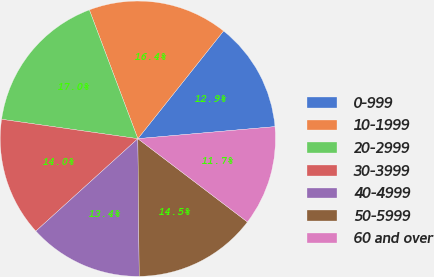<chart> <loc_0><loc_0><loc_500><loc_500><pie_chart><fcel>0-999<fcel>10-1999<fcel>20-2999<fcel>30-3999<fcel>40-4999<fcel>50-5999<fcel>60 and over<nl><fcel>12.91%<fcel>16.43%<fcel>17.02%<fcel>13.97%<fcel>13.44%<fcel>14.5%<fcel>11.74%<nl></chart> 